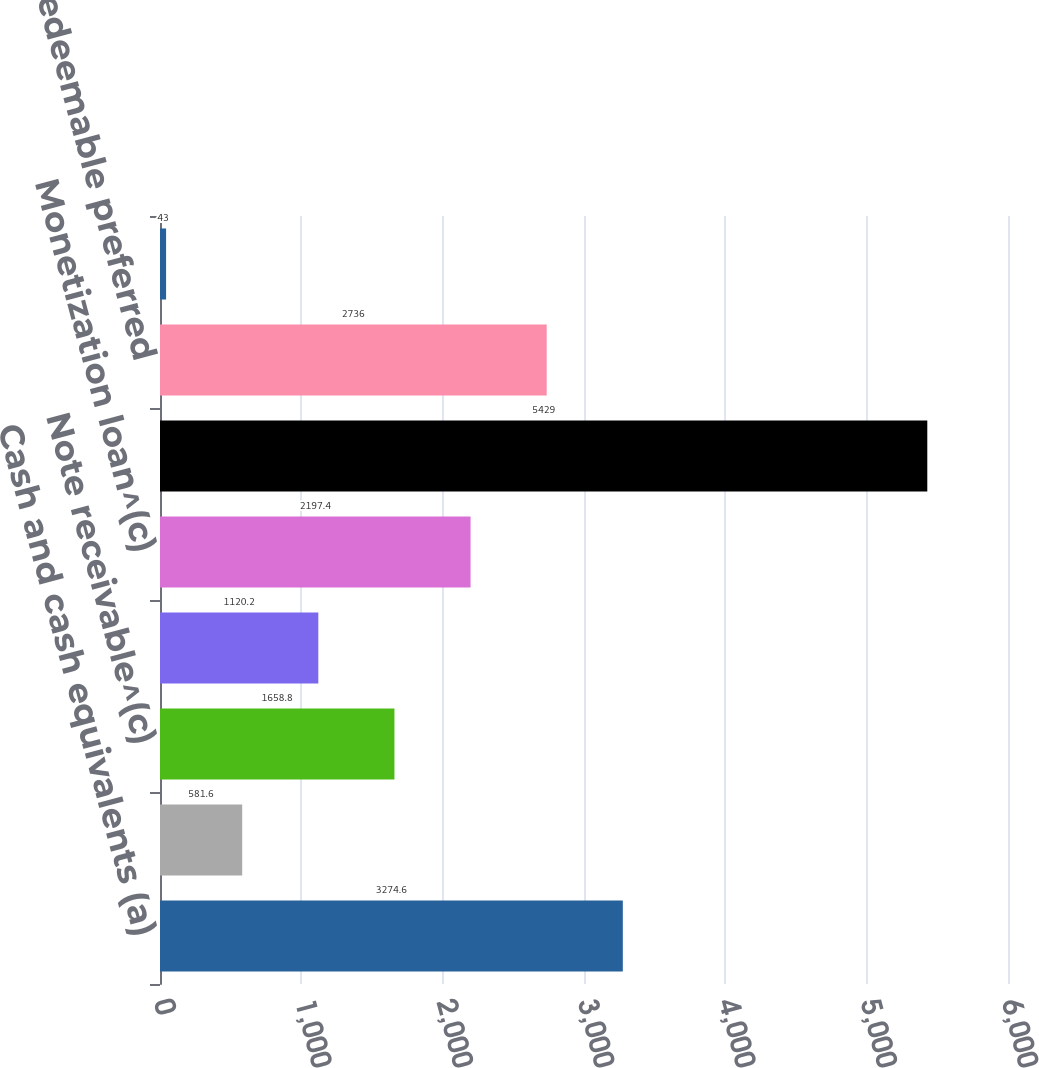Convert chart. <chart><loc_0><loc_0><loc_500><loc_500><bar_chart><fcel>Cash and cash equivalents (a)<fcel>Time deposits^(b)<fcel>Note receivable^(c)<fcel>Short-term debt^(d)<fcel>Monetization loan^(c)<fcel>Long-term debt (e)<fcel>Redeemable preferred<fcel>Redeemable common securities<nl><fcel>3274.6<fcel>581.6<fcel>1658.8<fcel>1120.2<fcel>2197.4<fcel>5429<fcel>2736<fcel>43<nl></chart> 